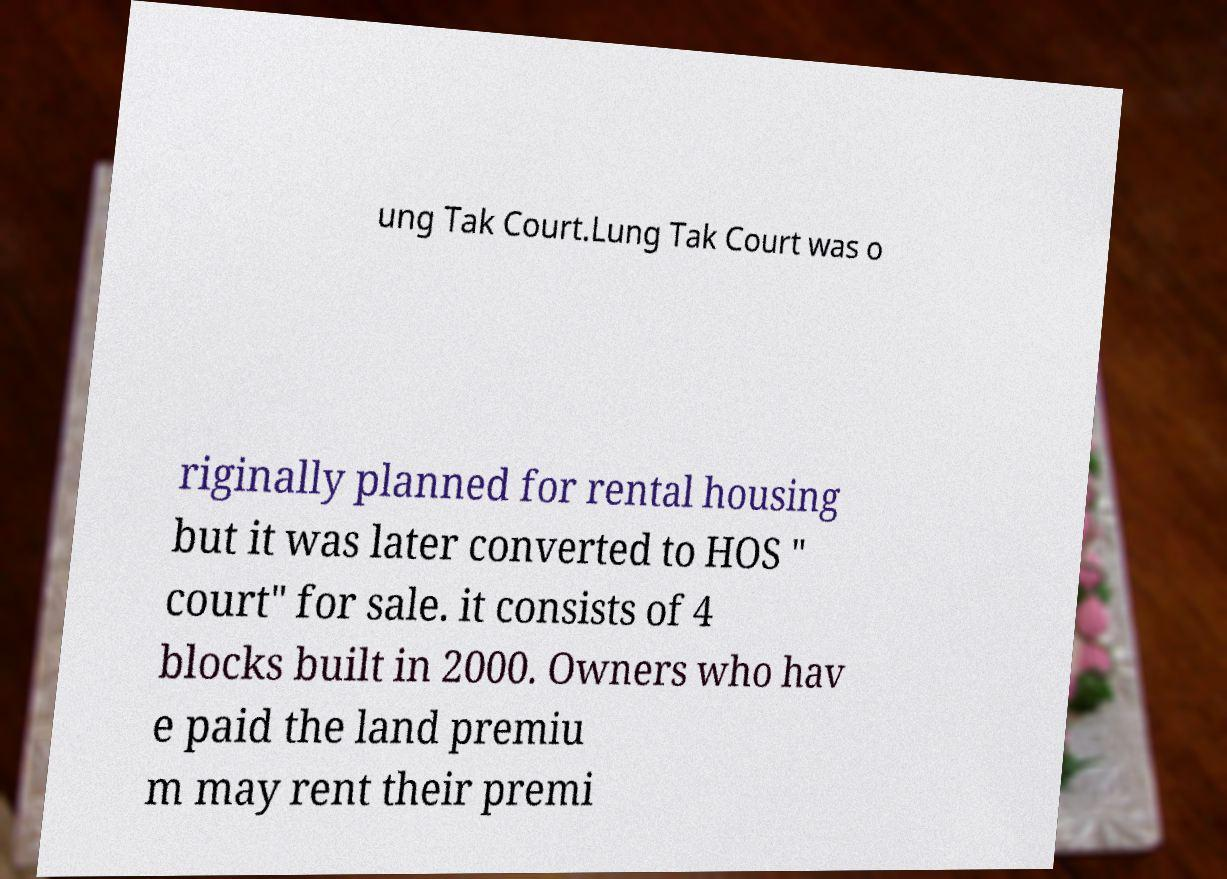Please identify and transcribe the text found in this image. ung Tak Court.Lung Tak Court was o riginally planned for rental housing but it was later converted to HOS " court" for sale. it consists of 4 blocks built in 2000. Owners who hav e paid the land premiu m may rent their premi 